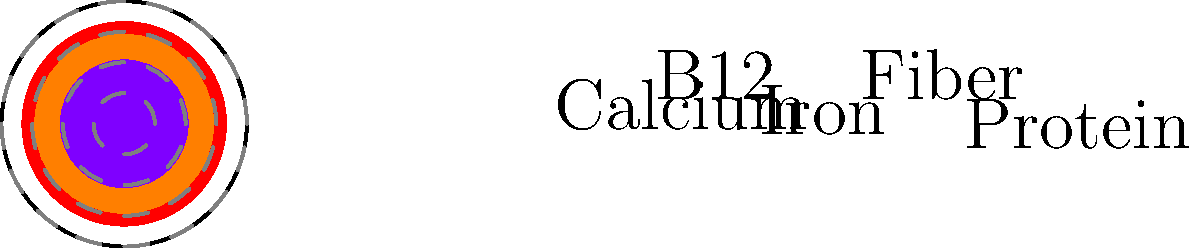Based on the polar area diagram showing nutritional content of a plant-based protein source, which nutrient appears to have the highest relative content? To determine which nutrient has the highest relative content, we need to compare the areas of each sector in the polar area diagram. The larger the area, the higher the relative content of that nutrient. Let's analyze each sector:

1. Protein (red): This sector has the largest area, extending almost to the outer circle.
2. Iron (green): This sector has a moderate area, smaller than protein but larger than some others.
3. Calcium (blue): This sector has the smallest area among all nutrients shown.
4. Fiber (orange): This sector has the second-largest area, close to but slightly smaller than protein.
5. B12 (purple): This sector has a moderate area, similar to iron but slightly smaller.

By comparing these areas, we can see that the red sector representing protein has the largest area, extending furthest from the center. This indicates that protein has the highest relative content among the nutrients shown in this plant-based protein source.
Answer: Protein 